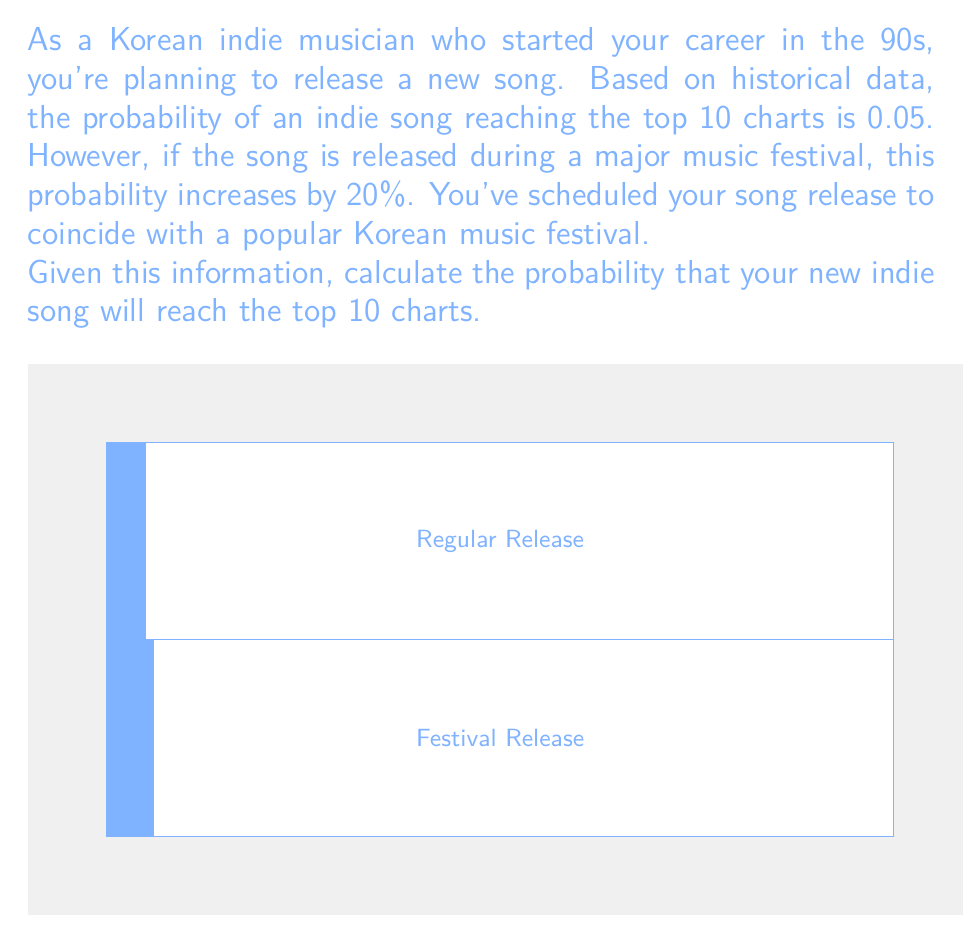Teach me how to tackle this problem. Let's approach this step-by-step:

1) First, we need to understand the given probabilities:
   - The base probability of an indie song reaching the top 10 charts is 0.05 or 5%.
   - During a major music festival, this probability increases by 20%.

2) To calculate the new probability during the festival, we need to increase the base probability by 20%:
   
   $$ \text{Increase} = 0.05 \times 20\% = 0.05 \times 0.2 = 0.01 $$

3) Now, we add this increase to the base probability:
   
   $$ \text{New Probability} = 0.05 + 0.01 = 0.06 $$

4) Therefore, the probability of your indie song reaching the top 10 charts when released during the Korean music festival is 0.06 or 6%.

This result shows that releasing your song during the festival increases your chances of reaching the top 10 charts from 5% to 6%, which is a significant boost for an indie artist.
Answer: 0.06 